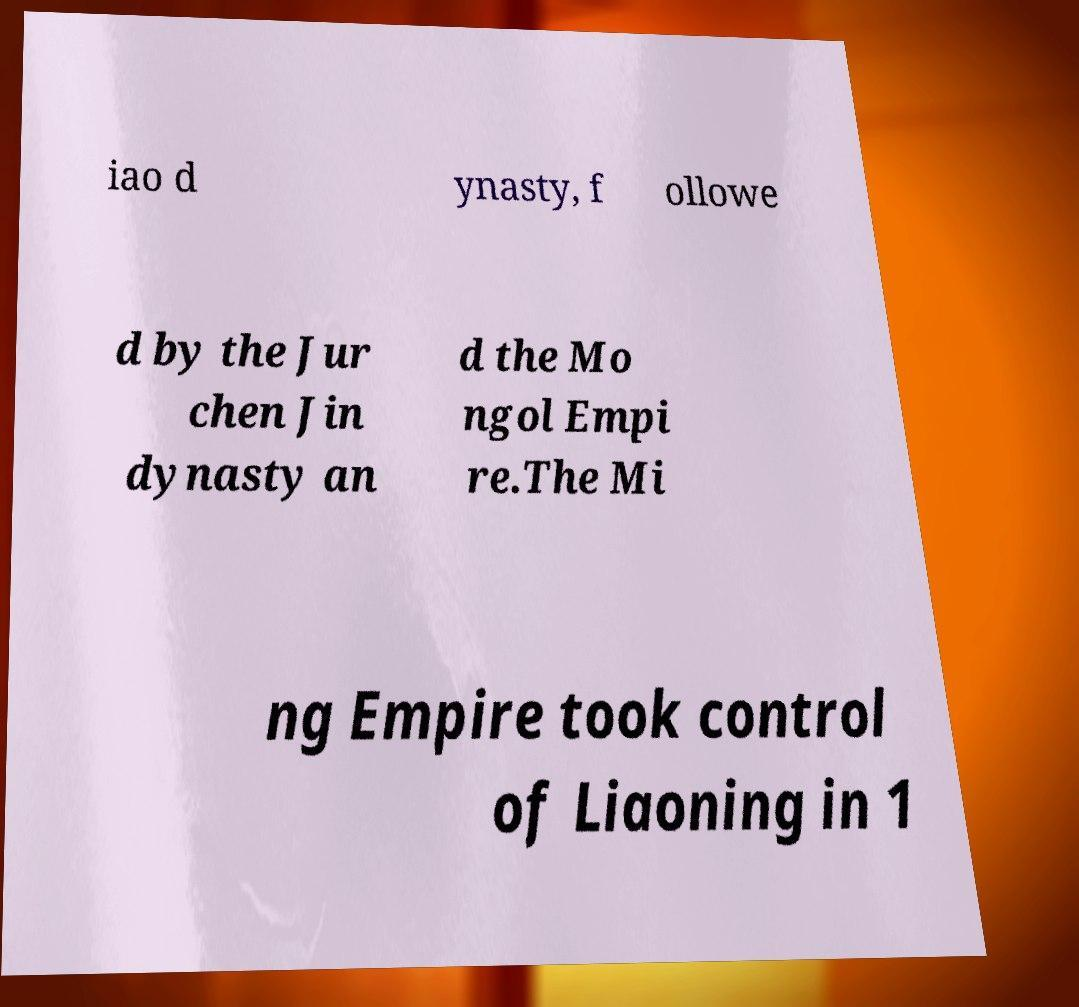For documentation purposes, I need the text within this image transcribed. Could you provide that? iao d ynasty, f ollowe d by the Jur chen Jin dynasty an d the Mo ngol Empi re.The Mi ng Empire took control of Liaoning in 1 